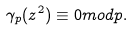Convert formula to latex. <formula><loc_0><loc_0><loc_500><loc_500>\gamma _ { p } ( z ^ { 2 } ) \equiv 0 m o d p .</formula> 